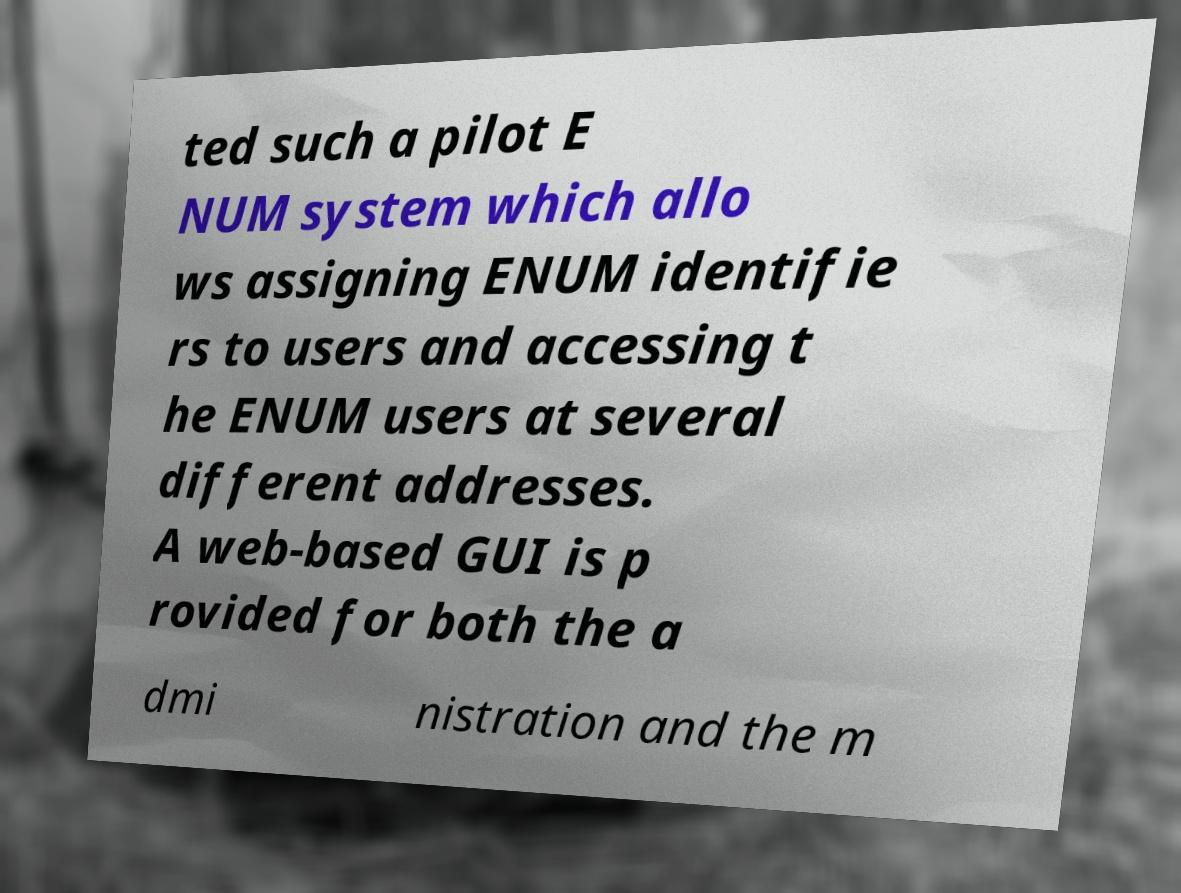Please identify and transcribe the text found in this image. ted such a pilot E NUM system which allo ws assigning ENUM identifie rs to users and accessing t he ENUM users at several different addresses. A web-based GUI is p rovided for both the a dmi nistration and the m 